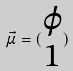Convert formula to latex. <formula><loc_0><loc_0><loc_500><loc_500>\vec { \mu } = ( \begin{matrix} \varphi \\ 1 \end{matrix} )</formula> 